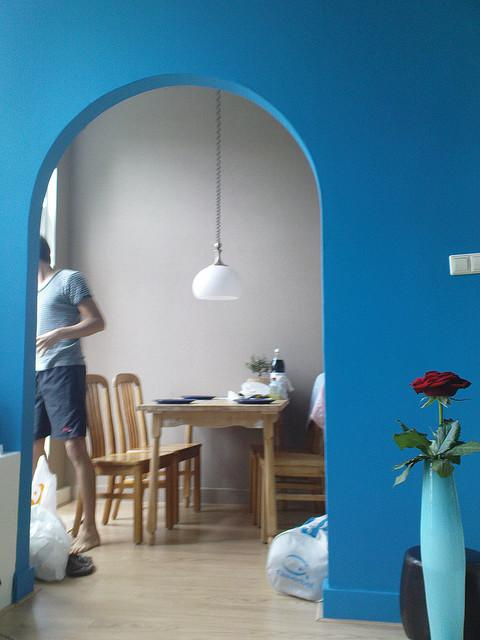What is furthest to the right? Please explain your reasoning. flower. The object furthest to the right is a tall blue vase with a red flower in it. 